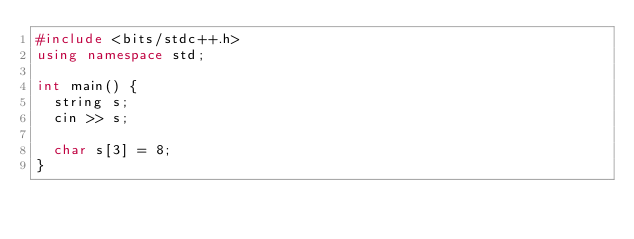Convert code to text. <code><loc_0><loc_0><loc_500><loc_500><_C++_>#include <bits/stdc++.h>
using namespace std;

int main() {
  string s;
  cin >> s;
  
  char s[3] = 8;
}  </code> 